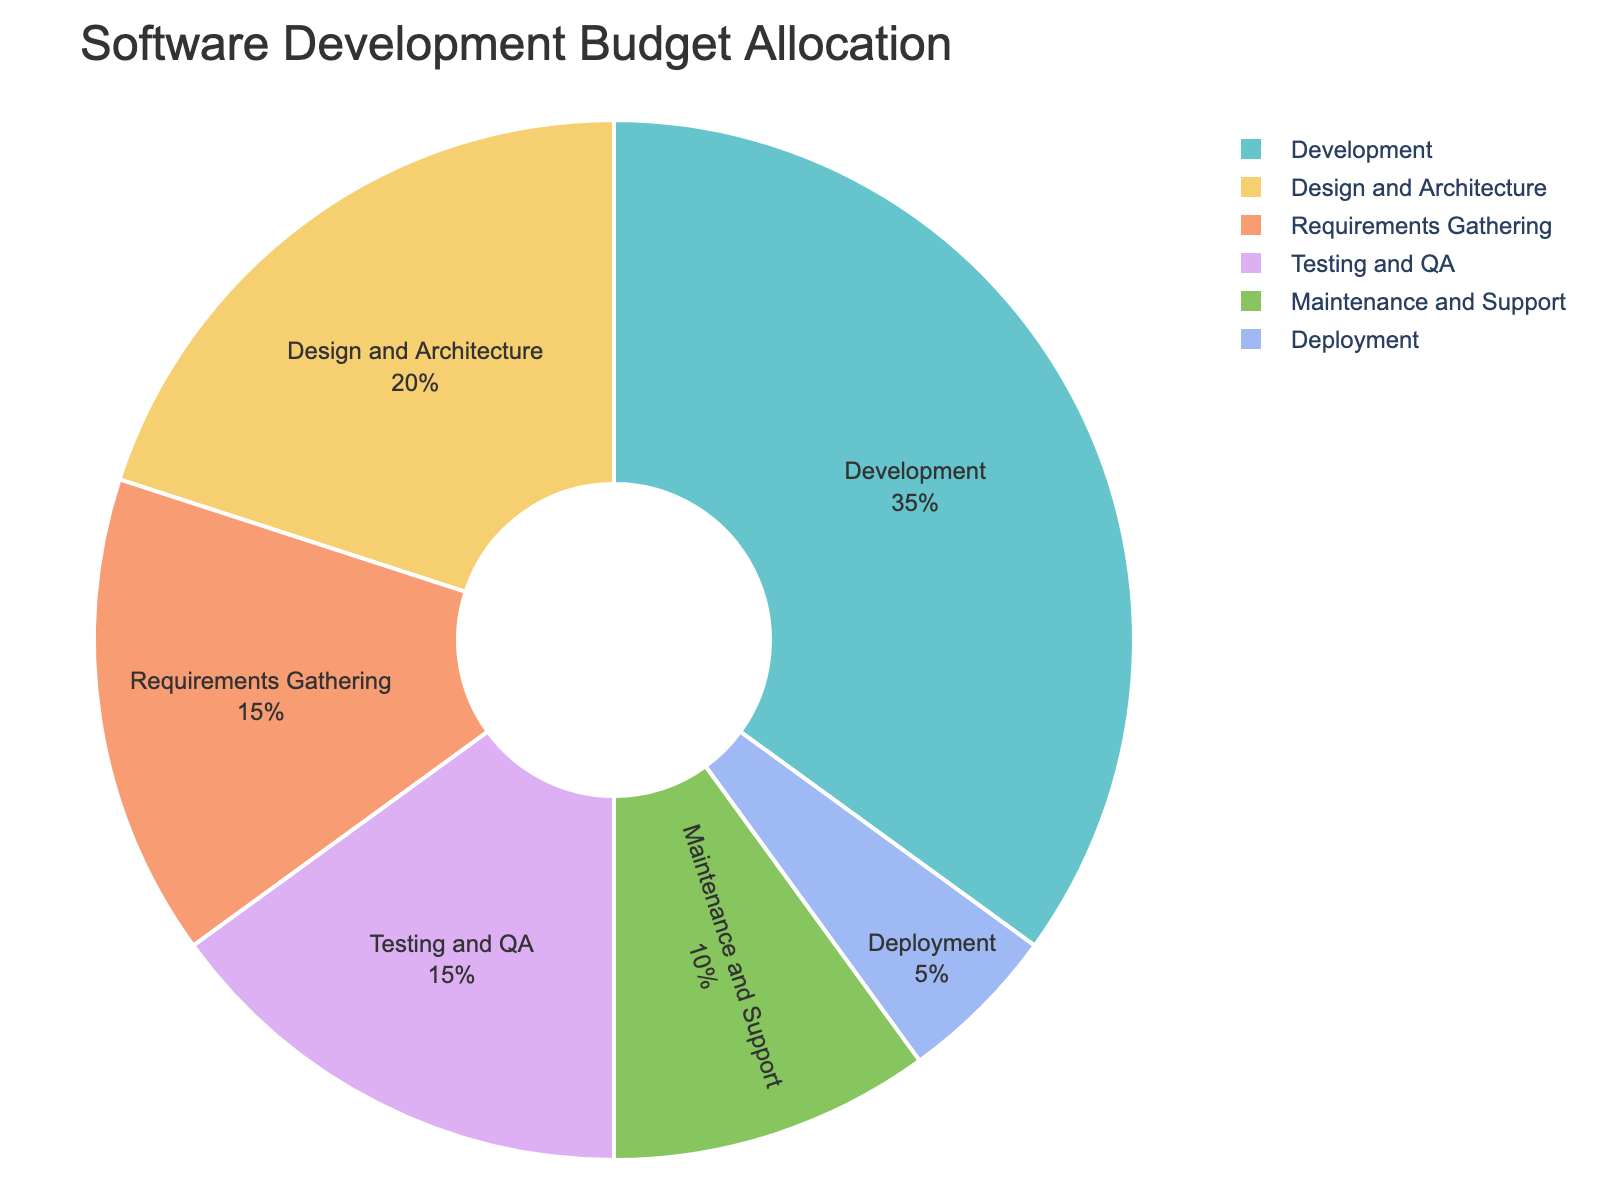How much of the budget is allocated to the initial phases of the software development lifecycle (Requirements Gathering and Design and Architecture)? The budget for Requirements Gathering is 15% and for Design and Architecture is 20%. Adding them together gives 15% + 20% = 35%.
Answer: 35% Which phase receives the highest budget allocation? The Development phase receives the highest budget allocation with 35% of the total budget.
Answer: Development How does the budget allocation for Testing and QA compare to that for Maintenance and Support? The Testing and QA phase has a 15% allocation, while Maintenance and Support have a 10% allocation. Comparing them, Testing and QA have a 5% higher allocation than Maintenance and Support.
Answer: Testing and QA has 5% more What percentage of the budget is allocated to the final phases of the software development lifecycle (Deployment and Maintenance and Support)? The budget for Deployment is 5% and for Maintenance and Support is 10%. Adding them together gives 5% + 10% = 15%.
Answer: 15% If the Development phase's budget were reduced by 5%, how would its new percentage compare to the Design and Architecture phase? The Development phase currently has 35%. Reducing it by 5% gives 35% - 5% = 30%. The Design and Architecture phase has 20%, so the Development phase would still be 10% higher.
Answer: 10% higher Which phases together make up half of the software development budget? To make up half of the budget, we need a total of 50%. The Development phase alone is 35%. Adding the Design and Architecture phase, which is 20%, gives 35% + 20% = 55%. Since 55% is more than half, just the Development phase and another phase less than 15% would not work, but Development and Design and Architecture contributes more than half.
Answer: Development and Design What is the difference in budget allocation between the most funded and the least funded phases? The most funded phase is Development at 35%, and the least funded phase is Deployment at 5%. The difference is 35% - 5% = 30%.
Answer: 30% Which phases combined have a budget allocation nearly equal to the Development phase? The Development phase is 35%. Combining Requirements Gathering (15%) and Design and Architecture (20%) gives 15% + 20% = 35%, which is equal to the Development phase.
Answer: Requirements Gathering and Design and Architecture If the budget for Maintenance and Support were doubled, what would its new allocation be? The current allocation for Maintenance and Support is 10%. Doubling it would give 10% * 2 = 20%.
Answer: 20% Is the total budget for Testing and QA greater than the combined budget of Deployment and Maintenance and Support? Testing and QA has a budget of 15%, and Deployment and Maintenance and Support together have 5% + 10% = 15%. The total budget for Testing and QA equals that of Deployment and Maintenance and Support.
Answer: No, they are equal 